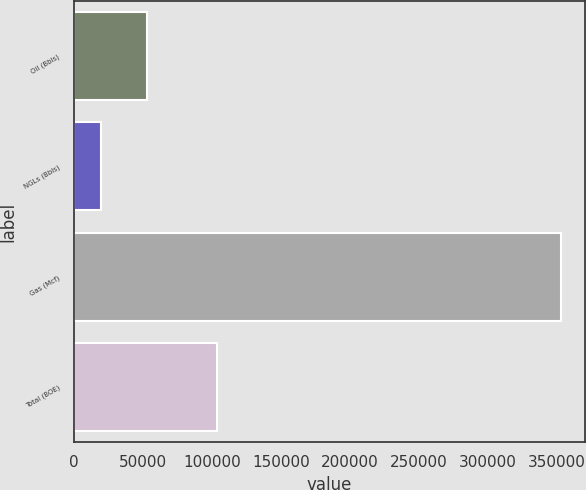<chart> <loc_0><loc_0><loc_500><loc_500><bar_chart><fcel>Oil (Bbls)<fcel>NGLs (Bbls)<fcel>Gas (Mcf)<fcel>Total (BOE)<nl><fcel>52986.9<fcel>19680<fcel>352749<fcel>103440<nl></chart> 